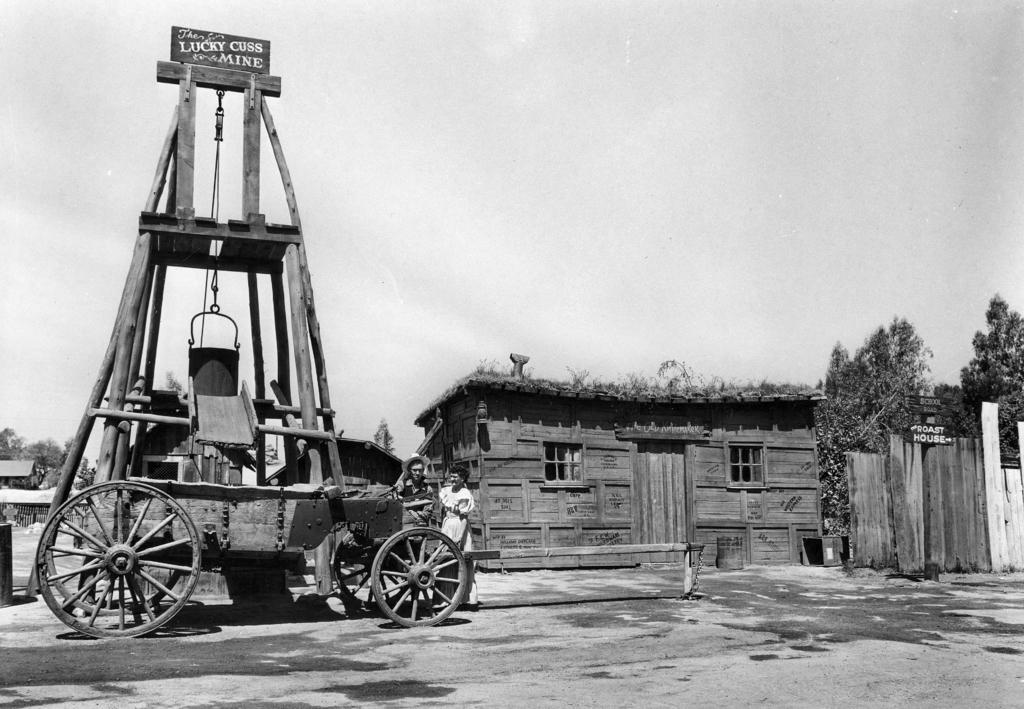What can be seen in the middle of the picture? There are trees, a building, people, and a wooden vehicle in the middle of the picture. What type of surface is visible in the foreground of the picture? There is soil in the foreground of the picture. What is visible at the top of the picture? The sky is visible at the top of the picture. What type of metal object can be seen in the picture? There is no metal object present in the image. Are there any worms visible in the picture? There are no worms visible in the picture. What type of breakfast is being served in the picture? There is no breakfast present in the image. 